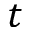<formula> <loc_0><loc_0><loc_500><loc_500>t</formula> 